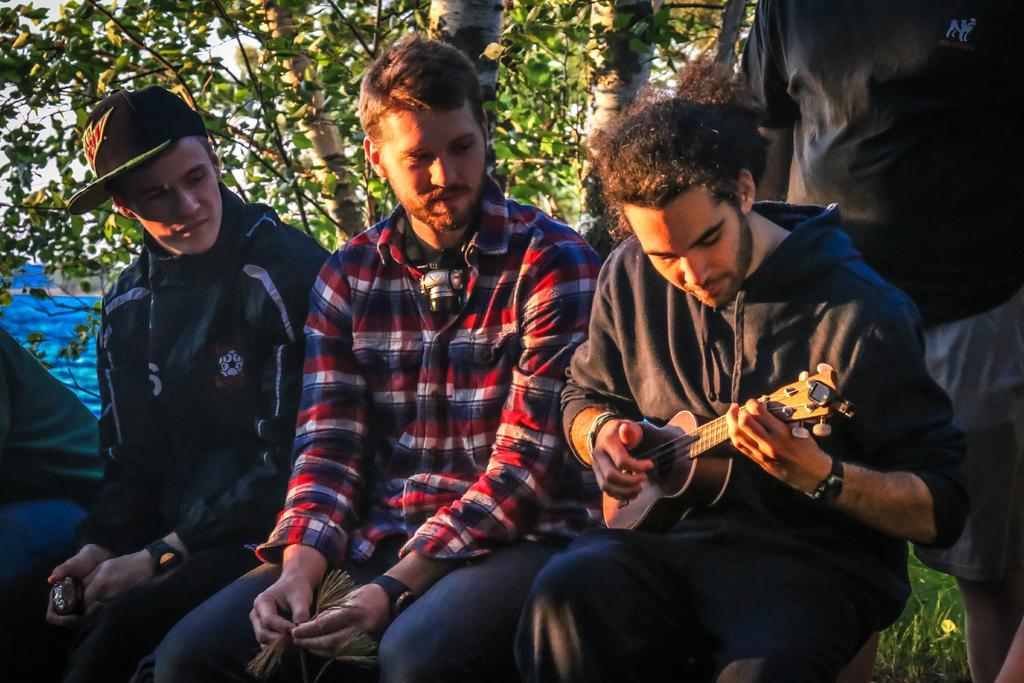Please provide a concise description of this image. As we can see in the image there is a tree and four people over here. Three of them are sitting and the man who is sitting here is holding guitar. 